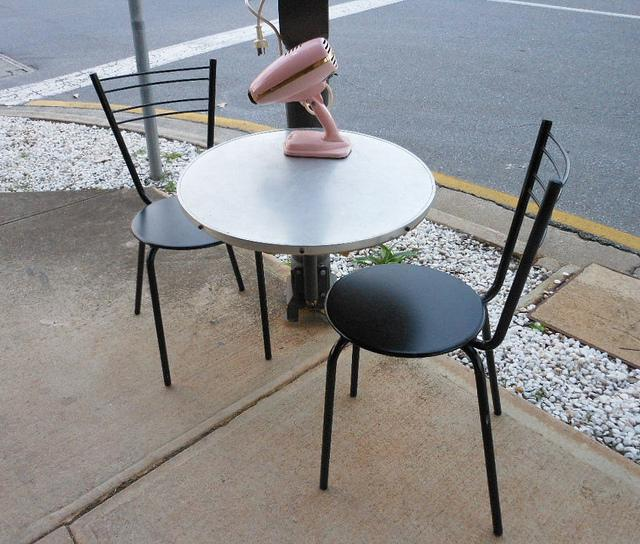What type of electronic is on the table? hair dryer 